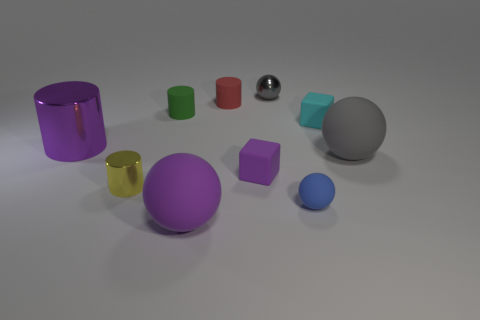Subtract 1 balls. How many balls are left? 3 Subtract all cubes. How many objects are left? 8 Subtract all purple matte balls. Subtract all blocks. How many objects are left? 7 Add 4 large things. How many large things are left? 7 Add 2 large purple matte spheres. How many large purple matte spheres exist? 3 Subtract 0 brown balls. How many objects are left? 10 